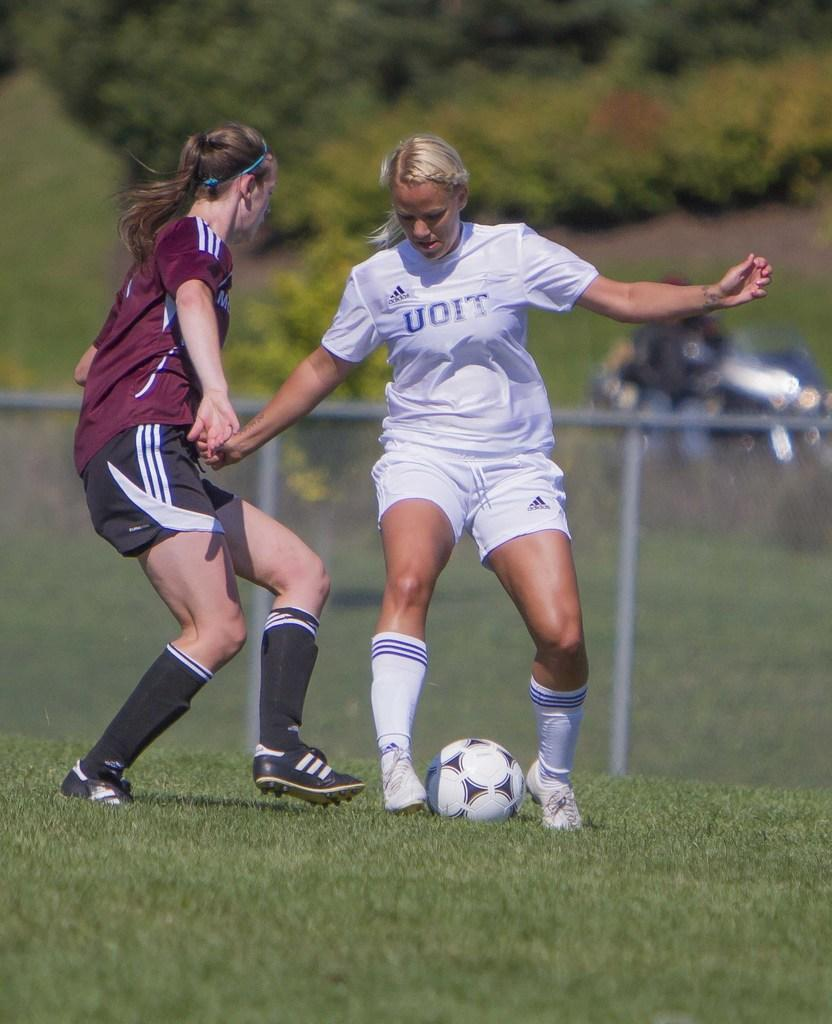How many people are in the image? There are two women in the image. What activity are the women engaged in? The women are playing football. What action are the women attempting to perform? The women are trying to kick the football. Where is the football being played? The football is being played on a grassy land. What can be seen in the background of the image? There is a fence and plants in the background of the image. What type of humor can be seen in the image? There is no humor present in the image; it depicts two women playing football on a grassy land. 